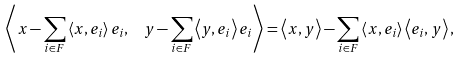<formula> <loc_0><loc_0><loc_500><loc_500>\left \langle x - \sum _ { i \in F } \left \langle x , e _ { i } \right \rangle e _ { i } , \ \ y - \sum _ { i \in F } \left \langle y , e _ { i } \right \rangle e _ { i } \right \rangle = \left \langle x , y \right \rangle - \sum _ { i \in F } \left \langle x , e _ { i } \right \rangle \left \langle e _ { i } , y \right \rangle ,</formula> 